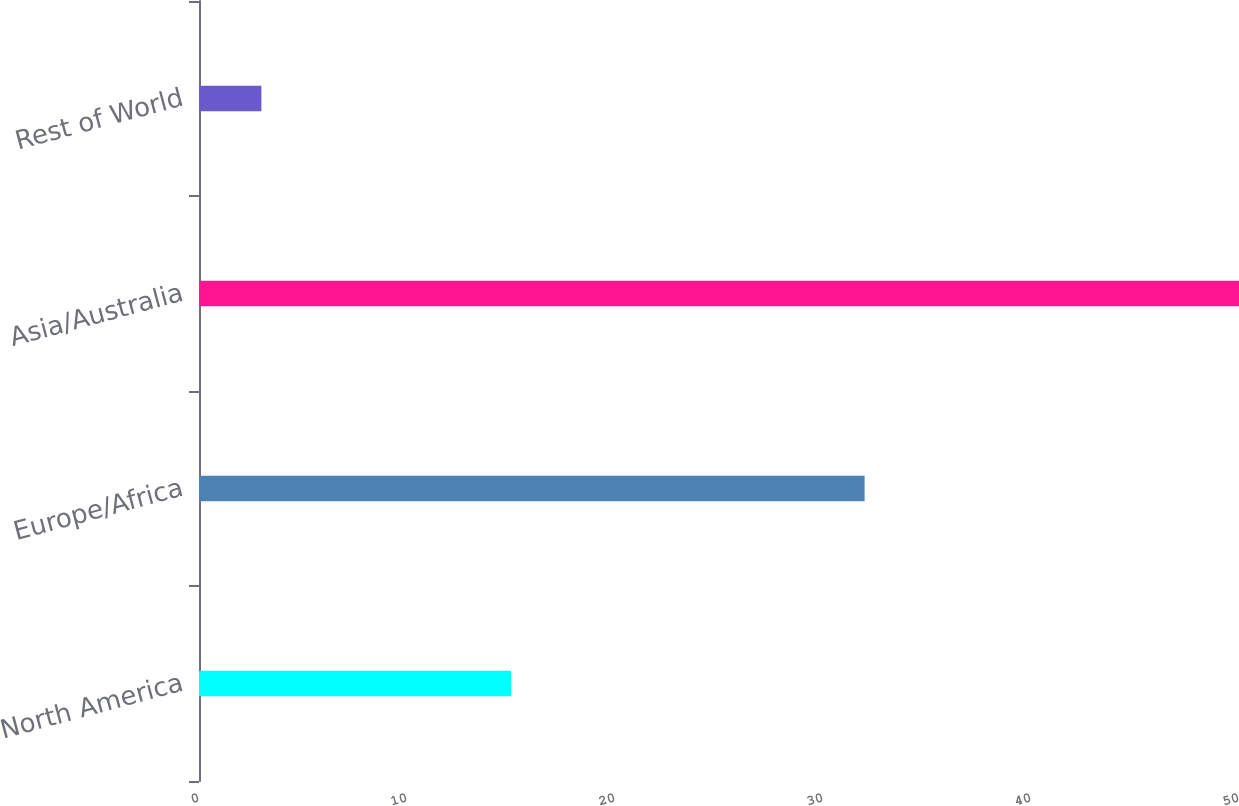Convert chart to OTSL. <chart><loc_0><loc_0><loc_500><loc_500><bar_chart><fcel>North America<fcel>Europe/Africa<fcel>Asia/Australia<fcel>Rest of World<nl><fcel>15<fcel>32<fcel>50<fcel>3<nl></chart> 